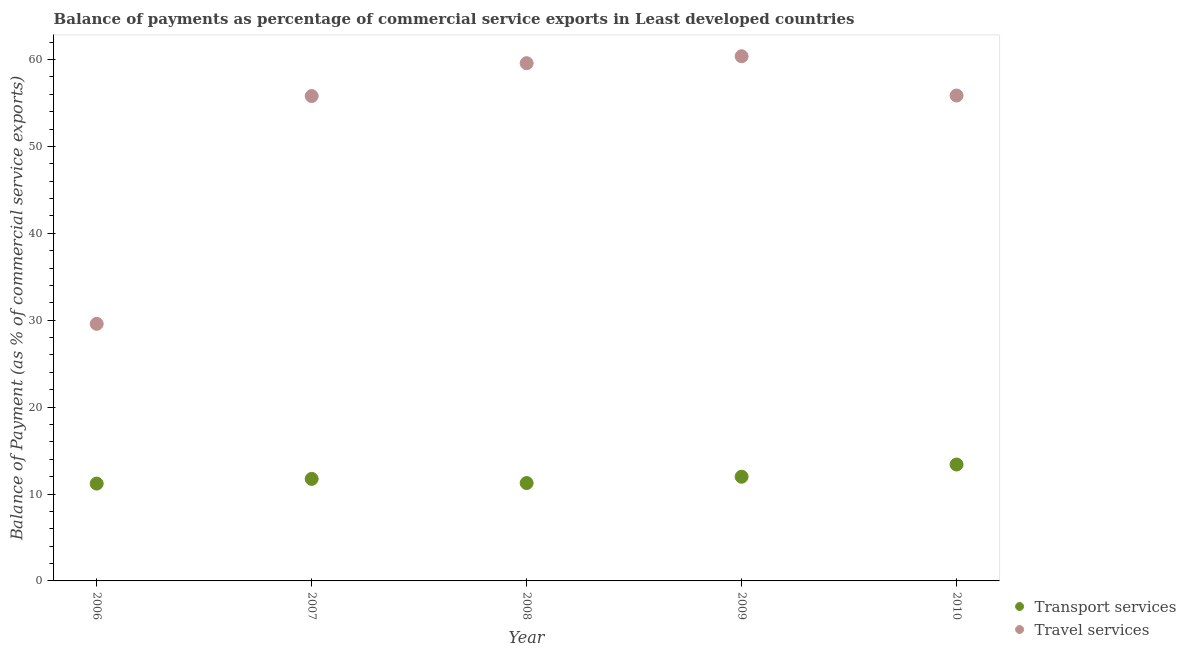How many different coloured dotlines are there?
Ensure brevity in your answer.  2. What is the balance of payments of travel services in 2006?
Provide a short and direct response. 29.58. Across all years, what is the maximum balance of payments of transport services?
Your response must be concise. 13.39. Across all years, what is the minimum balance of payments of transport services?
Provide a short and direct response. 11.2. In which year was the balance of payments of transport services minimum?
Your response must be concise. 2006. What is the total balance of payments of travel services in the graph?
Provide a short and direct response. 261.17. What is the difference between the balance of payments of travel services in 2008 and that in 2010?
Provide a succinct answer. 3.72. What is the difference between the balance of payments of transport services in 2007 and the balance of payments of travel services in 2010?
Provide a short and direct response. -44.11. What is the average balance of payments of travel services per year?
Offer a very short reply. 52.23. In the year 2009, what is the difference between the balance of payments of travel services and balance of payments of transport services?
Offer a terse response. 48.38. What is the ratio of the balance of payments of travel services in 2008 to that in 2009?
Provide a short and direct response. 0.99. Is the balance of payments of transport services in 2006 less than that in 2008?
Give a very brief answer. Yes. Is the difference between the balance of payments of transport services in 2006 and 2008 greater than the difference between the balance of payments of travel services in 2006 and 2008?
Provide a short and direct response. Yes. What is the difference between the highest and the second highest balance of payments of travel services?
Make the answer very short. 0.8. What is the difference between the highest and the lowest balance of payments of transport services?
Your answer should be very brief. 2.19. In how many years, is the balance of payments of travel services greater than the average balance of payments of travel services taken over all years?
Provide a succinct answer. 4. Is the sum of the balance of payments of travel services in 2008 and 2009 greater than the maximum balance of payments of transport services across all years?
Your answer should be very brief. Yes. Does the balance of payments of travel services monotonically increase over the years?
Offer a very short reply. No. Is the balance of payments of transport services strictly greater than the balance of payments of travel services over the years?
Offer a very short reply. No. How many years are there in the graph?
Provide a short and direct response. 5. What is the difference between two consecutive major ticks on the Y-axis?
Your response must be concise. 10. Are the values on the major ticks of Y-axis written in scientific E-notation?
Keep it short and to the point. No. How many legend labels are there?
Offer a very short reply. 2. How are the legend labels stacked?
Offer a terse response. Vertical. What is the title of the graph?
Provide a succinct answer. Balance of payments as percentage of commercial service exports in Least developed countries. Does "Male labourers" appear as one of the legend labels in the graph?
Your answer should be very brief. No. What is the label or title of the Y-axis?
Ensure brevity in your answer.  Balance of Payment (as % of commercial service exports). What is the Balance of Payment (as % of commercial service exports) in Transport services in 2006?
Your answer should be compact. 11.2. What is the Balance of Payment (as % of commercial service exports) in Travel services in 2006?
Offer a very short reply. 29.58. What is the Balance of Payment (as % of commercial service exports) of Transport services in 2007?
Provide a short and direct response. 11.74. What is the Balance of Payment (as % of commercial service exports) of Travel services in 2007?
Give a very brief answer. 55.79. What is the Balance of Payment (as % of commercial service exports) of Transport services in 2008?
Your answer should be compact. 11.26. What is the Balance of Payment (as % of commercial service exports) in Travel services in 2008?
Make the answer very short. 59.57. What is the Balance of Payment (as % of commercial service exports) in Transport services in 2009?
Your answer should be very brief. 11.99. What is the Balance of Payment (as % of commercial service exports) in Travel services in 2009?
Provide a succinct answer. 60.37. What is the Balance of Payment (as % of commercial service exports) in Transport services in 2010?
Your answer should be compact. 13.39. What is the Balance of Payment (as % of commercial service exports) of Travel services in 2010?
Provide a short and direct response. 55.85. Across all years, what is the maximum Balance of Payment (as % of commercial service exports) in Transport services?
Provide a short and direct response. 13.39. Across all years, what is the maximum Balance of Payment (as % of commercial service exports) of Travel services?
Your answer should be very brief. 60.37. Across all years, what is the minimum Balance of Payment (as % of commercial service exports) in Transport services?
Provide a succinct answer. 11.2. Across all years, what is the minimum Balance of Payment (as % of commercial service exports) in Travel services?
Make the answer very short. 29.58. What is the total Balance of Payment (as % of commercial service exports) in Transport services in the graph?
Your response must be concise. 59.59. What is the total Balance of Payment (as % of commercial service exports) of Travel services in the graph?
Offer a terse response. 261.17. What is the difference between the Balance of Payment (as % of commercial service exports) of Transport services in 2006 and that in 2007?
Your answer should be compact. -0.54. What is the difference between the Balance of Payment (as % of commercial service exports) of Travel services in 2006 and that in 2007?
Keep it short and to the point. -26.21. What is the difference between the Balance of Payment (as % of commercial service exports) of Transport services in 2006 and that in 2008?
Ensure brevity in your answer.  -0.06. What is the difference between the Balance of Payment (as % of commercial service exports) in Travel services in 2006 and that in 2008?
Keep it short and to the point. -29.99. What is the difference between the Balance of Payment (as % of commercial service exports) of Transport services in 2006 and that in 2009?
Provide a succinct answer. -0.79. What is the difference between the Balance of Payment (as % of commercial service exports) of Travel services in 2006 and that in 2009?
Provide a short and direct response. -30.79. What is the difference between the Balance of Payment (as % of commercial service exports) in Transport services in 2006 and that in 2010?
Make the answer very short. -2.19. What is the difference between the Balance of Payment (as % of commercial service exports) of Travel services in 2006 and that in 2010?
Make the answer very short. -26.27. What is the difference between the Balance of Payment (as % of commercial service exports) in Transport services in 2007 and that in 2008?
Your answer should be very brief. 0.48. What is the difference between the Balance of Payment (as % of commercial service exports) in Travel services in 2007 and that in 2008?
Your answer should be very brief. -3.78. What is the difference between the Balance of Payment (as % of commercial service exports) of Transport services in 2007 and that in 2009?
Offer a very short reply. -0.25. What is the difference between the Balance of Payment (as % of commercial service exports) in Travel services in 2007 and that in 2009?
Your answer should be compact. -4.58. What is the difference between the Balance of Payment (as % of commercial service exports) in Transport services in 2007 and that in 2010?
Ensure brevity in your answer.  -1.65. What is the difference between the Balance of Payment (as % of commercial service exports) in Travel services in 2007 and that in 2010?
Your answer should be compact. -0.06. What is the difference between the Balance of Payment (as % of commercial service exports) of Transport services in 2008 and that in 2009?
Give a very brief answer. -0.73. What is the difference between the Balance of Payment (as % of commercial service exports) in Travel services in 2008 and that in 2009?
Keep it short and to the point. -0.8. What is the difference between the Balance of Payment (as % of commercial service exports) in Transport services in 2008 and that in 2010?
Ensure brevity in your answer.  -2.13. What is the difference between the Balance of Payment (as % of commercial service exports) of Travel services in 2008 and that in 2010?
Offer a terse response. 3.72. What is the difference between the Balance of Payment (as % of commercial service exports) of Transport services in 2009 and that in 2010?
Offer a very short reply. -1.41. What is the difference between the Balance of Payment (as % of commercial service exports) of Travel services in 2009 and that in 2010?
Provide a succinct answer. 4.52. What is the difference between the Balance of Payment (as % of commercial service exports) in Transport services in 2006 and the Balance of Payment (as % of commercial service exports) in Travel services in 2007?
Offer a very short reply. -44.59. What is the difference between the Balance of Payment (as % of commercial service exports) of Transport services in 2006 and the Balance of Payment (as % of commercial service exports) of Travel services in 2008?
Your answer should be compact. -48.37. What is the difference between the Balance of Payment (as % of commercial service exports) of Transport services in 2006 and the Balance of Payment (as % of commercial service exports) of Travel services in 2009?
Your answer should be very brief. -49.17. What is the difference between the Balance of Payment (as % of commercial service exports) of Transport services in 2006 and the Balance of Payment (as % of commercial service exports) of Travel services in 2010?
Provide a succinct answer. -44.65. What is the difference between the Balance of Payment (as % of commercial service exports) of Transport services in 2007 and the Balance of Payment (as % of commercial service exports) of Travel services in 2008?
Keep it short and to the point. -47.83. What is the difference between the Balance of Payment (as % of commercial service exports) in Transport services in 2007 and the Balance of Payment (as % of commercial service exports) in Travel services in 2009?
Give a very brief answer. -48.63. What is the difference between the Balance of Payment (as % of commercial service exports) of Transport services in 2007 and the Balance of Payment (as % of commercial service exports) of Travel services in 2010?
Your answer should be compact. -44.11. What is the difference between the Balance of Payment (as % of commercial service exports) in Transport services in 2008 and the Balance of Payment (as % of commercial service exports) in Travel services in 2009?
Your answer should be very brief. -49.11. What is the difference between the Balance of Payment (as % of commercial service exports) in Transport services in 2008 and the Balance of Payment (as % of commercial service exports) in Travel services in 2010?
Provide a short and direct response. -44.59. What is the difference between the Balance of Payment (as % of commercial service exports) of Transport services in 2009 and the Balance of Payment (as % of commercial service exports) of Travel services in 2010?
Give a very brief answer. -43.86. What is the average Balance of Payment (as % of commercial service exports) of Transport services per year?
Provide a short and direct response. 11.92. What is the average Balance of Payment (as % of commercial service exports) of Travel services per year?
Provide a short and direct response. 52.23. In the year 2006, what is the difference between the Balance of Payment (as % of commercial service exports) in Transport services and Balance of Payment (as % of commercial service exports) in Travel services?
Your answer should be compact. -18.38. In the year 2007, what is the difference between the Balance of Payment (as % of commercial service exports) of Transport services and Balance of Payment (as % of commercial service exports) of Travel services?
Your response must be concise. -44.05. In the year 2008, what is the difference between the Balance of Payment (as % of commercial service exports) of Transport services and Balance of Payment (as % of commercial service exports) of Travel services?
Make the answer very short. -48.31. In the year 2009, what is the difference between the Balance of Payment (as % of commercial service exports) of Transport services and Balance of Payment (as % of commercial service exports) of Travel services?
Make the answer very short. -48.38. In the year 2010, what is the difference between the Balance of Payment (as % of commercial service exports) in Transport services and Balance of Payment (as % of commercial service exports) in Travel services?
Give a very brief answer. -42.46. What is the ratio of the Balance of Payment (as % of commercial service exports) in Transport services in 2006 to that in 2007?
Provide a short and direct response. 0.95. What is the ratio of the Balance of Payment (as % of commercial service exports) in Travel services in 2006 to that in 2007?
Your answer should be very brief. 0.53. What is the ratio of the Balance of Payment (as % of commercial service exports) in Travel services in 2006 to that in 2008?
Ensure brevity in your answer.  0.5. What is the ratio of the Balance of Payment (as % of commercial service exports) in Transport services in 2006 to that in 2009?
Offer a very short reply. 0.93. What is the ratio of the Balance of Payment (as % of commercial service exports) of Travel services in 2006 to that in 2009?
Make the answer very short. 0.49. What is the ratio of the Balance of Payment (as % of commercial service exports) of Transport services in 2006 to that in 2010?
Your answer should be very brief. 0.84. What is the ratio of the Balance of Payment (as % of commercial service exports) in Travel services in 2006 to that in 2010?
Keep it short and to the point. 0.53. What is the ratio of the Balance of Payment (as % of commercial service exports) in Transport services in 2007 to that in 2008?
Your answer should be compact. 1.04. What is the ratio of the Balance of Payment (as % of commercial service exports) of Travel services in 2007 to that in 2008?
Ensure brevity in your answer.  0.94. What is the ratio of the Balance of Payment (as % of commercial service exports) of Transport services in 2007 to that in 2009?
Offer a very short reply. 0.98. What is the ratio of the Balance of Payment (as % of commercial service exports) of Travel services in 2007 to that in 2009?
Provide a succinct answer. 0.92. What is the ratio of the Balance of Payment (as % of commercial service exports) in Transport services in 2007 to that in 2010?
Keep it short and to the point. 0.88. What is the ratio of the Balance of Payment (as % of commercial service exports) of Travel services in 2007 to that in 2010?
Provide a short and direct response. 1. What is the ratio of the Balance of Payment (as % of commercial service exports) in Transport services in 2008 to that in 2009?
Offer a terse response. 0.94. What is the ratio of the Balance of Payment (as % of commercial service exports) in Transport services in 2008 to that in 2010?
Provide a short and direct response. 0.84. What is the ratio of the Balance of Payment (as % of commercial service exports) in Travel services in 2008 to that in 2010?
Your response must be concise. 1.07. What is the ratio of the Balance of Payment (as % of commercial service exports) in Transport services in 2009 to that in 2010?
Provide a succinct answer. 0.9. What is the ratio of the Balance of Payment (as % of commercial service exports) of Travel services in 2009 to that in 2010?
Keep it short and to the point. 1.08. What is the difference between the highest and the second highest Balance of Payment (as % of commercial service exports) of Transport services?
Provide a short and direct response. 1.41. What is the difference between the highest and the second highest Balance of Payment (as % of commercial service exports) of Travel services?
Give a very brief answer. 0.8. What is the difference between the highest and the lowest Balance of Payment (as % of commercial service exports) of Transport services?
Make the answer very short. 2.19. What is the difference between the highest and the lowest Balance of Payment (as % of commercial service exports) of Travel services?
Offer a very short reply. 30.79. 